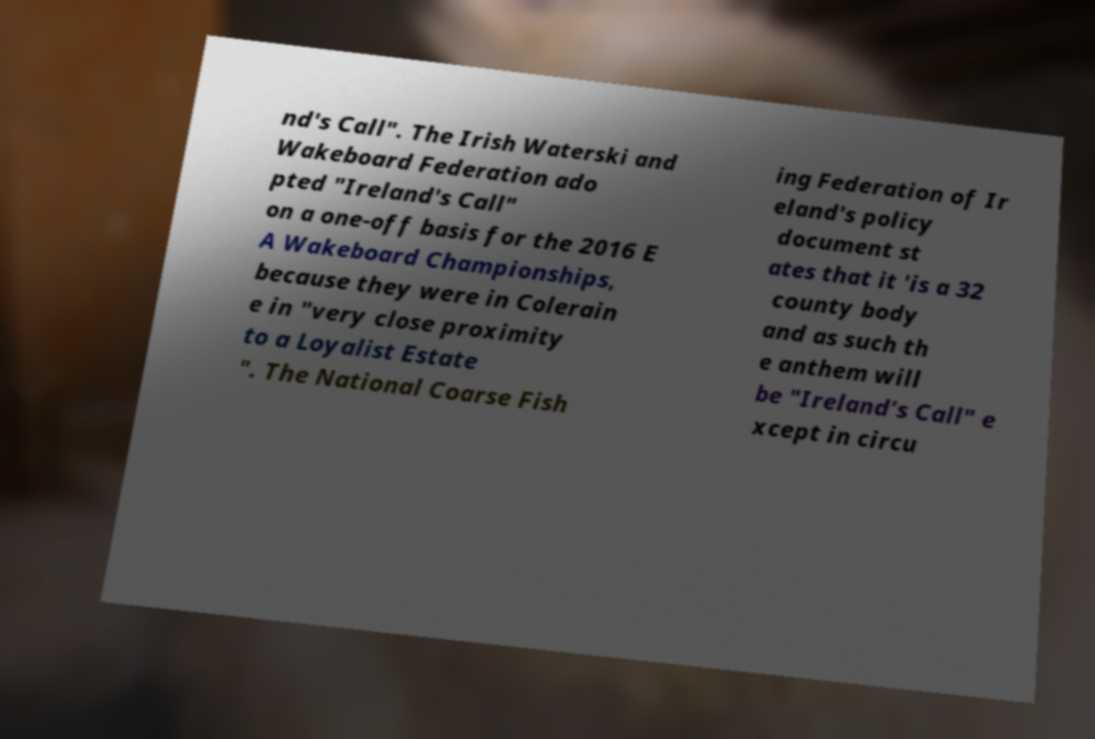Can you read and provide the text displayed in the image?This photo seems to have some interesting text. Can you extract and type it out for me? nd's Call". The Irish Waterski and Wakeboard Federation ado pted "Ireland's Call" on a one-off basis for the 2016 E A Wakeboard Championships, because they were in Colerain e in "very close proximity to a Loyalist Estate ". The National Coarse Fish ing Federation of Ir eland's policy document st ates that it 'is a 32 county body and as such th e anthem will be "Ireland’s Call" e xcept in circu 